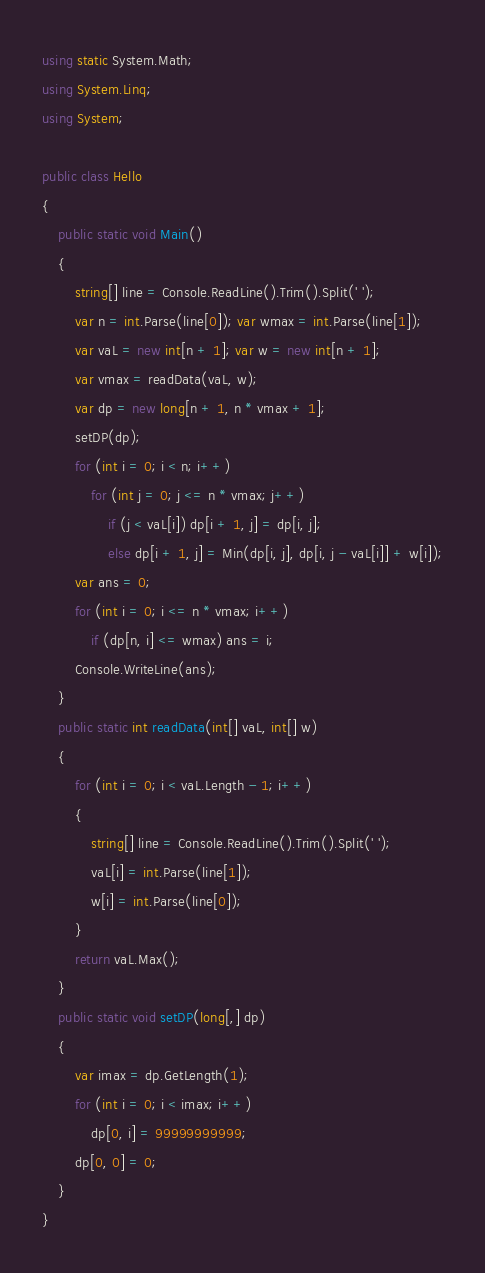<code> <loc_0><loc_0><loc_500><loc_500><_C#_>using static System.Math;
using System.Linq;
using System;

public class Hello
{
    public static void Main()
    {
        string[] line = Console.ReadLine().Trim().Split(' ');
        var n = int.Parse(line[0]); var wmax = int.Parse(line[1]);
        var vaL = new int[n + 1]; var w = new int[n + 1];
        var vmax = readData(vaL, w);
        var dp = new long[n + 1, n * vmax + 1];
        setDP(dp);
        for (int i = 0; i < n; i++)
            for (int j = 0; j <= n * vmax; j++)
                if (j < vaL[i]) dp[i + 1, j] = dp[i, j];
                else dp[i + 1, j] = Min(dp[i, j], dp[i, j - vaL[i]] + w[i]);
        var ans = 0;
        for (int i = 0; i <= n * vmax; i++)
            if (dp[n, i] <= wmax) ans = i;
        Console.WriteLine(ans);
    }
    public static int readData(int[] vaL, int[] w)
    {
        for (int i = 0; i < vaL.Length - 1; i++)
        {
            string[] line = Console.ReadLine().Trim().Split(' ');
            vaL[i] = int.Parse(line[1]);
            w[i] = int.Parse(line[0]);
        }
        return vaL.Max();
    }
    public static void setDP(long[,] dp)
    {
        var imax = dp.GetLength(1);
        for (int i = 0; i < imax; i++)
            dp[0, i] = 99999999999;
        dp[0, 0] = 0;
    }
}</code> 